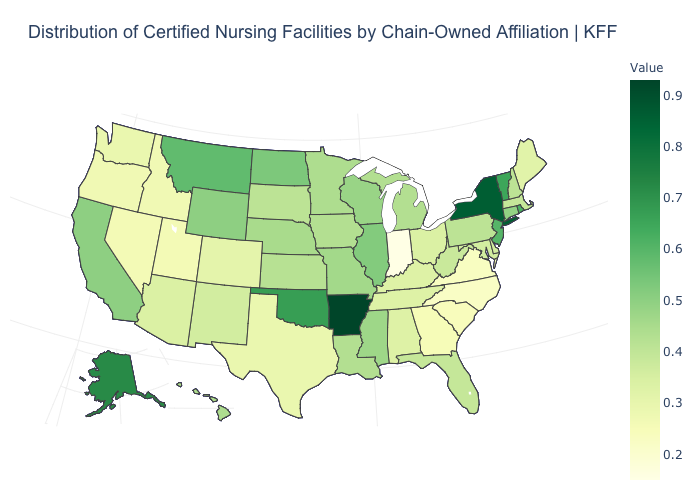Which states have the highest value in the USA?
Write a very short answer. Arkansas. Does Minnesota have the highest value in the USA?
Write a very short answer. No. Among the states that border North Dakota , which have the highest value?
Short answer required. Montana. Does Minnesota have a higher value than New Jersey?
Give a very brief answer. No. 